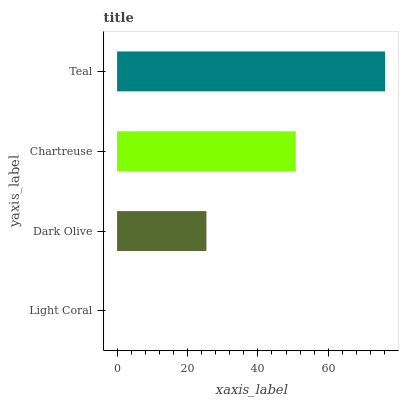Is Light Coral the minimum?
Answer yes or no. Yes. Is Teal the maximum?
Answer yes or no. Yes. Is Dark Olive the minimum?
Answer yes or no. No. Is Dark Olive the maximum?
Answer yes or no. No. Is Dark Olive greater than Light Coral?
Answer yes or no. Yes. Is Light Coral less than Dark Olive?
Answer yes or no. Yes. Is Light Coral greater than Dark Olive?
Answer yes or no. No. Is Dark Olive less than Light Coral?
Answer yes or no. No. Is Chartreuse the high median?
Answer yes or no. Yes. Is Dark Olive the low median?
Answer yes or no. Yes. Is Light Coral the high median?
Answer yes or no. No. Is Teal the low median?
Answer yes or no. No. 